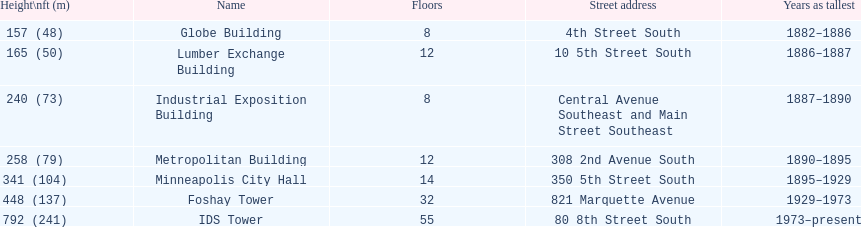How long did the lumber exchange building stand as the tallest building? 1 year. 